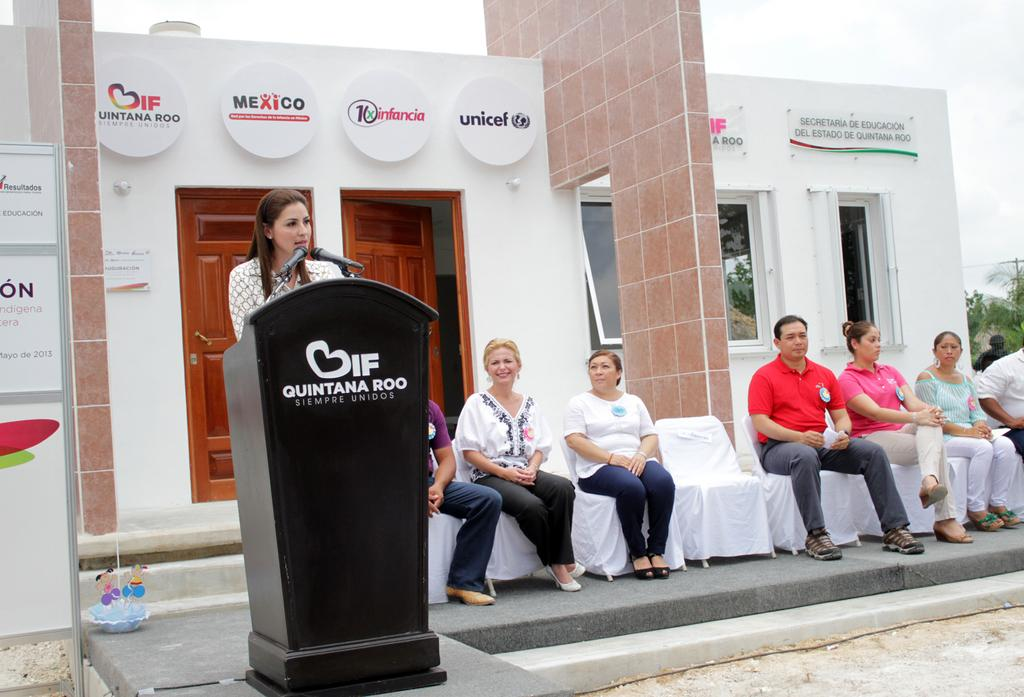<image>
Write a terse but informative summary of the picture. A woman at a Quintana Roo podium is giving a speech. 